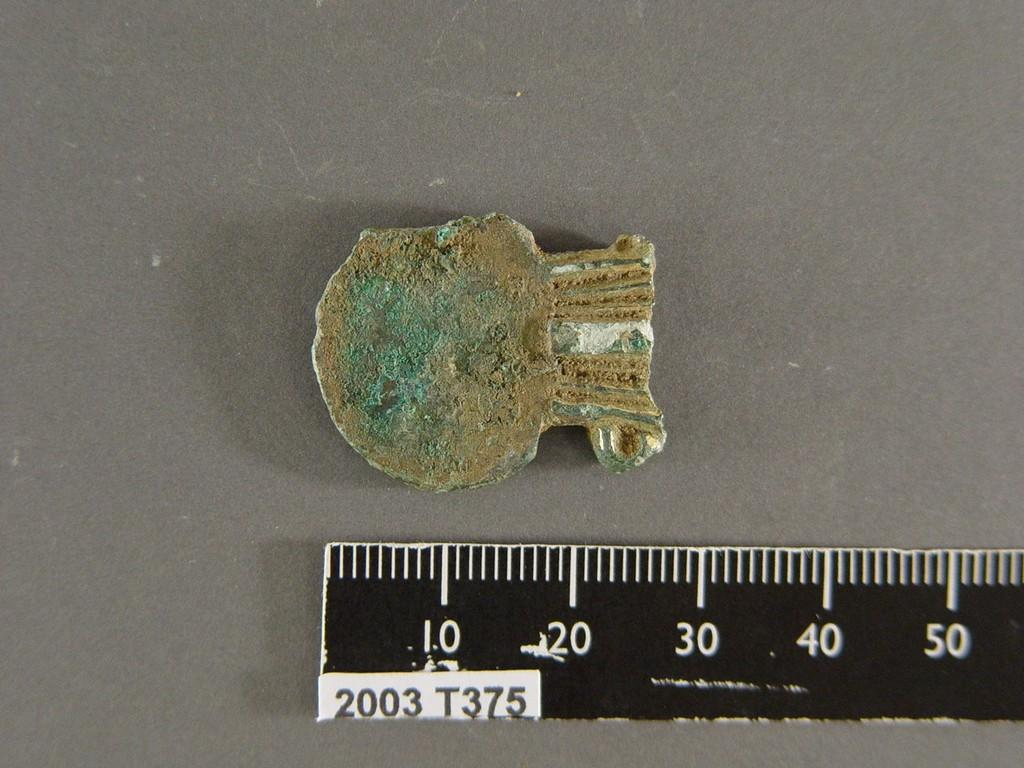<image>
Summarize the visual content of the image. A fossil is being measured on a ruler that reads 2003 T375 